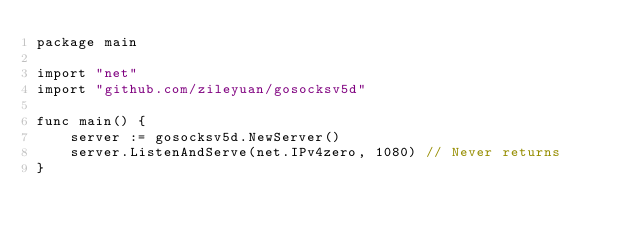Convert code to text. <code><loc_0><loc_0><loc_500><loc_500><_Go_>package main

import "net"
import "github.com/zileyuan/gosocksv5d"

func main() {
	server := gosocksv5d.NewServer()
	server.ListenAndServe(net.IPv4zero, 1080) // Never returns
}
</code> 